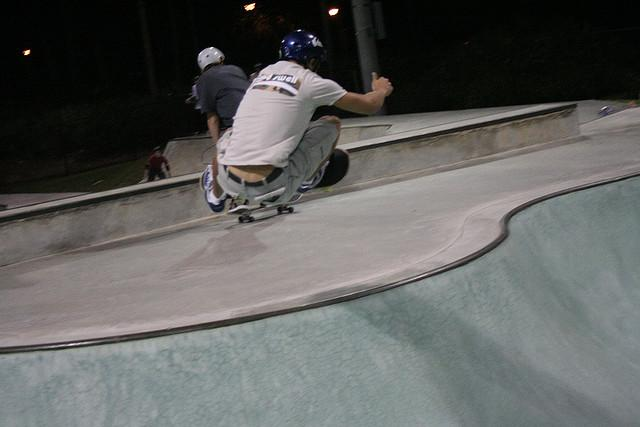World skate is the head controller of which game? Please explain your reasoning. skating. Skating is used for gaming. 